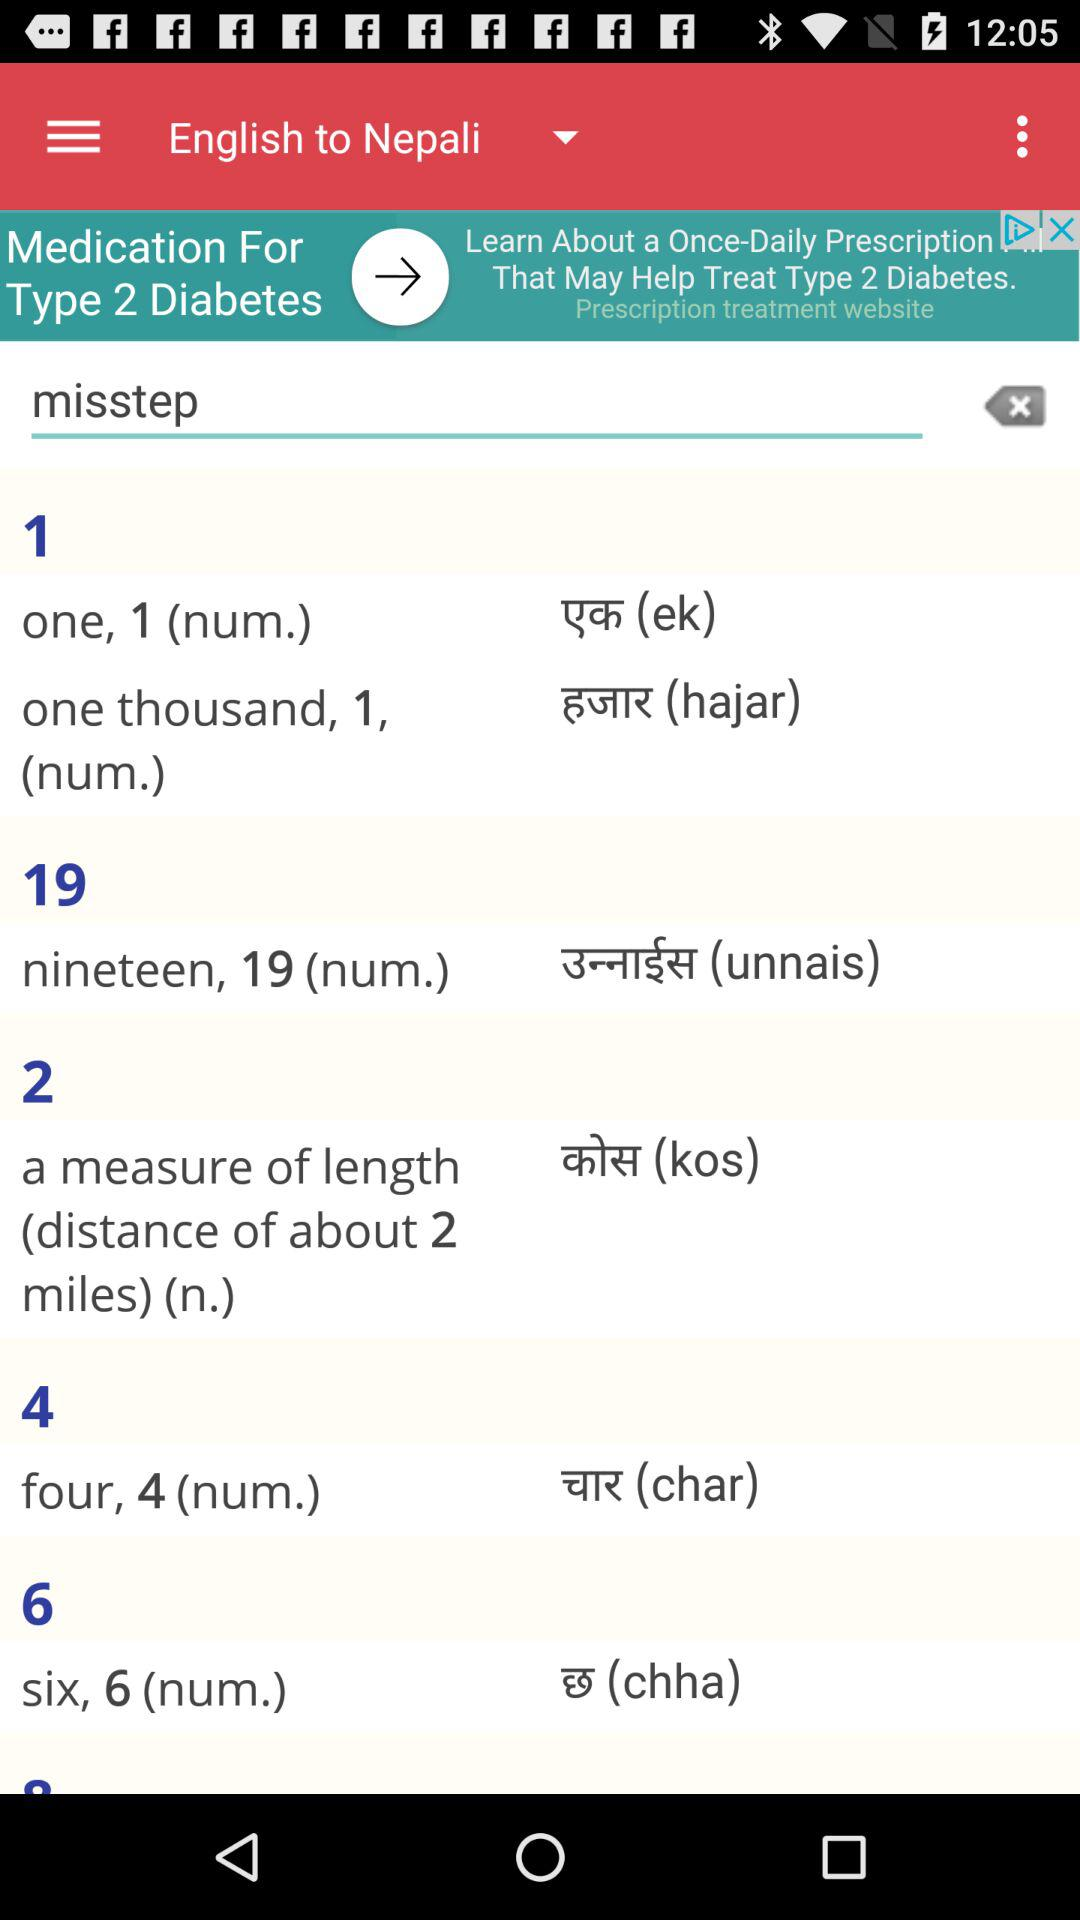What type of dictionary is selected? The type of selected dictionary is "English to Nepali". 